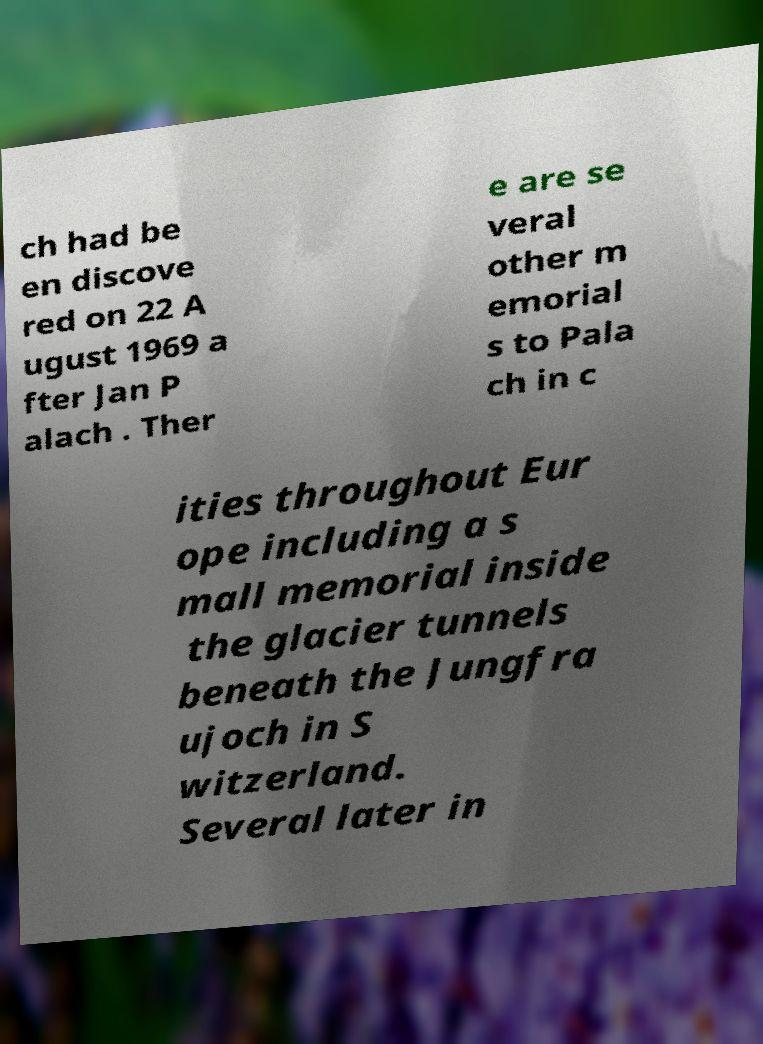There's text embedded in this image that I need extracted. Can you transcribe it verbatim? ch had be en discove red on 22 A ugust 1969 a fter Jan P alach . Ther e are se veral other m emorial s to Pala ch in c ities throughout Eur ope including a s mall memorial inside the glacier tunnels beneath the Jungfra ujoch in S witzerland. Several later in 